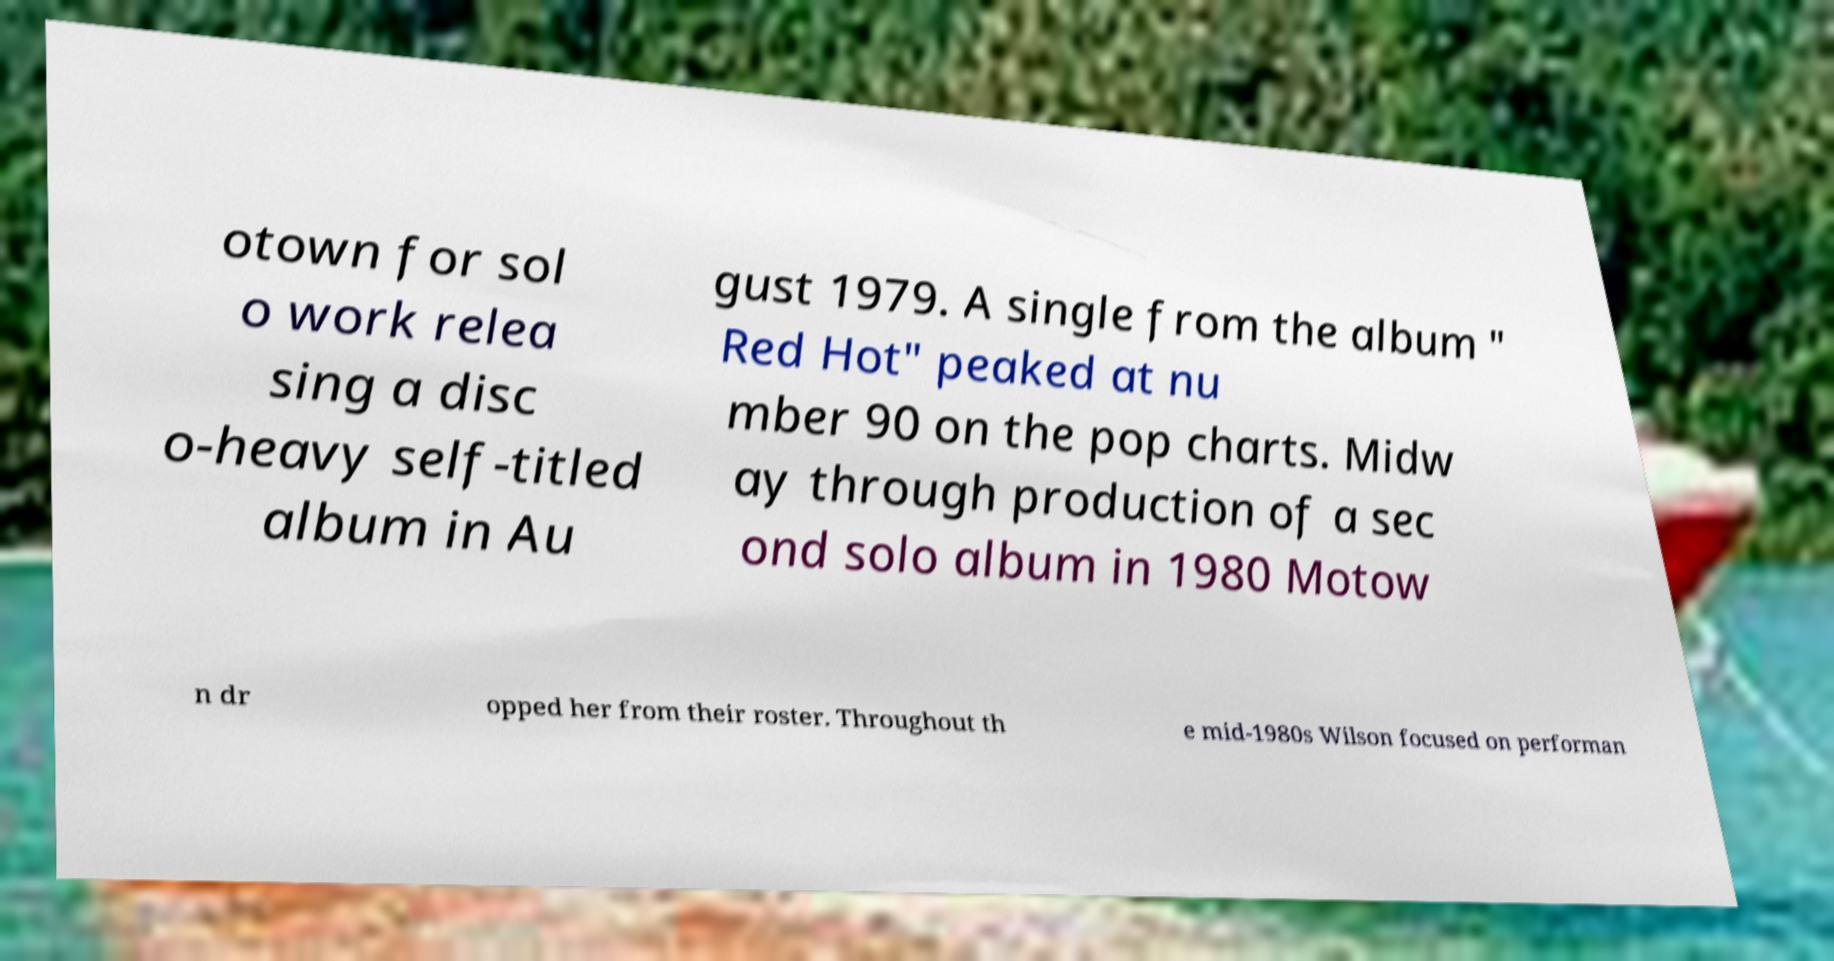Please identify and transcribe the text found in this image. otown for sol o work relea sing a disc o-heavy self-titled album in Au gust 1979. A single from the album " Red Hot" peaked at nu mber 90 on the pop charts. Midw ay through production of a sec ond solo album in 1980 Motow n dr opped her from their roster. Throughout th e mid-1980s Wilson focused on performan 